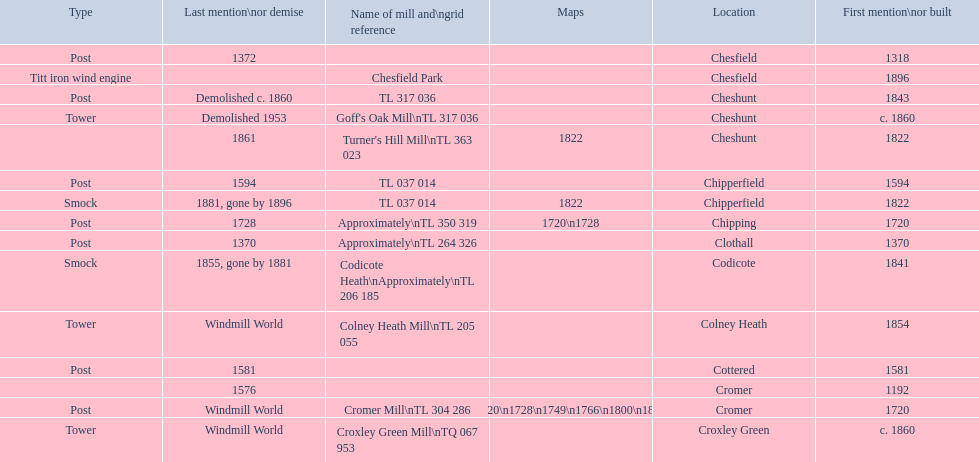Could you help me parse every detail presented in this table? {'header': ['Type', 'Last mention\\nor demise', 'Name of mill and\\ngrid reference', 'Maps', 'Location', 'First mention\\nor built'], 'rows': [['Post', '1372', '', '', 'Chesfield', '1318'], ['Titt iron wind engine', '', 'Chesfield Park', '', 'Chesfield', '1896'], ['Post', 'Demolished c. 1860', 'TL 317 036', '', 'Cheshunt', '1843'], ['Tower', 'Demolished 1953', "Goff's Oak Mill\\nTL 317 036", '', 'Cheshunt', 'c. 1860'], ['', '1861', "Turner's Hill Mill\\nTL 363 023", '1822', 'Cheshunt', '1822'], ['Post', '1594', 'TL 037 014', '', 'Chipperfield', '1594'], ['Smock', '1881, gone by 1896', 'TL 037 014', '1822', 'Chipperfield', '1822'], ['Post', '1728', 'Approximately\\nTL 350 319', '1720\\n1728', 'Chipping', '1720'], ['Post', '1370', 'Approximately\\nTL 264 326', '', 'Clothall', '1370'], ['Smock', '1855, gone by 1881', 'Codicote Heath\\nApproximately\\nTL 206 185', '', 'Codicote', '1841'], ['Tower', 'Windmill World', 'Colney Heath Mill\\nTL 205 055', '', 'Colney Heath', '1854'], ['Post', '1581', '', '', 'Cottered', '1581'], ['', '1576', '', '', 'Cromer', '1192'], ['Post', 'Windmill World', 'Cromer Mill\\nTL 304 286', '1720\\n1728\\n1749\\n1766\\n1800\\n1822', 'Cromer', '1720'], ['Tower', 'Windmill World', 'Croxley Green Mill\\nTQ 067 953', '', 'Croxley Green', 'c. 1860']]} What is the number of mills first mentioned or built in the 1800s? 8. 